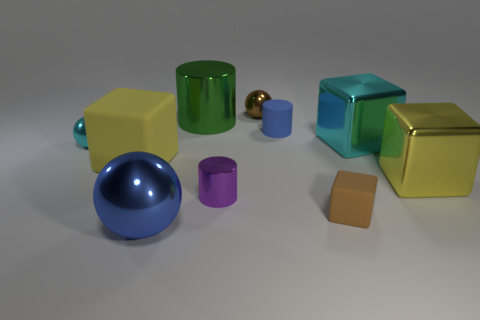Is the number of tiny brown rubber blocks less than the number of yellow things?
Your answer should be very brief. Yes. Is there a large cylinder of the same color as the large matte cube?
Your response must be concise. No. There is a large metallic object that is both behind the small cyan metallic thing and on the right side of the small brown block; what is its shape?
Your answer should be compact. Cube. What is the shape of the brown object that is behind the block on the left side of the tiny block?
Provide a succinct answer. Sphere. Is the small blue thing the same shape as the big yellow metallic thing?
Your response must be concise. No. There is a large object that is the same color as the large matte block; what material is it?
Give a very brief answer. Metal. Is the color of the small rubber block the same as the large cylinder?
Keep it short and to the point. No. There is a matte block on the right side of the tiny metal ball behind the large cylinder; what number of yellow objects are in front of it?
Offer a very short reply. 0. What is the shape of the brown thing that is the same material as the green object?
Make the answer very short. Sphere. What material is the cylinder in front of the small rubber cylinder that is behind the cube that is to the left of the blue sphere?
Your answer should be compact. Metal. 